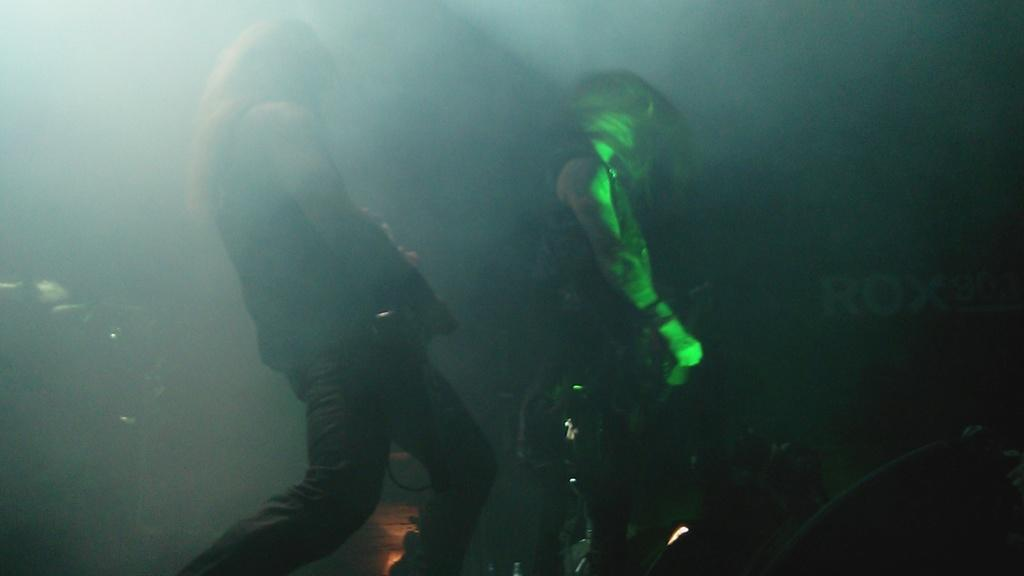How many people are in the image? There are two persons in the image. What are the two persons doing in the image? The two persons are standing. What are the two persons holding in their hands? The two persons are holding a guitar in their hands. What type of calendar is hanging on the wall behind the two persons? There is no calendar visible in the image. 